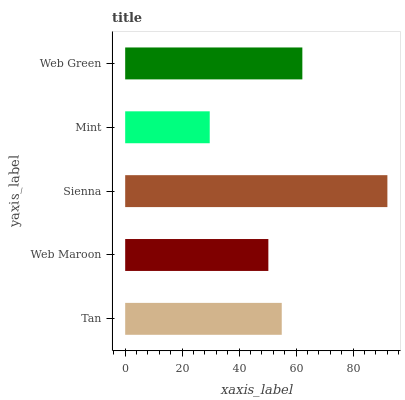Is Mint the minimum?
Answer yes or no. Yes. Is Sienna the maximum?
Answer yes or no. Yes. Is Web Maroon the minimum?
Answer yes or no. No. Is Web Maroon the maximum?
Answer yes or no. No. Is Tan greater than Web Maroon?
Answer yes or no. Yes. Is Web Maroon less than Tan?
Answer yes or no. Yes. Is Web Maroon greater than Tan?
Answer yes or no. No. Is Tan less than Web Maroon?
Answer yes or no. No. Is Tan the high median?
Answer yes or no. Yes. Is Tan the low median?
Answer yes or no. Yes. Is Mint the high median?
Answer yes or no. No. Is Web Green the low median?
Answer yes or no. No. 